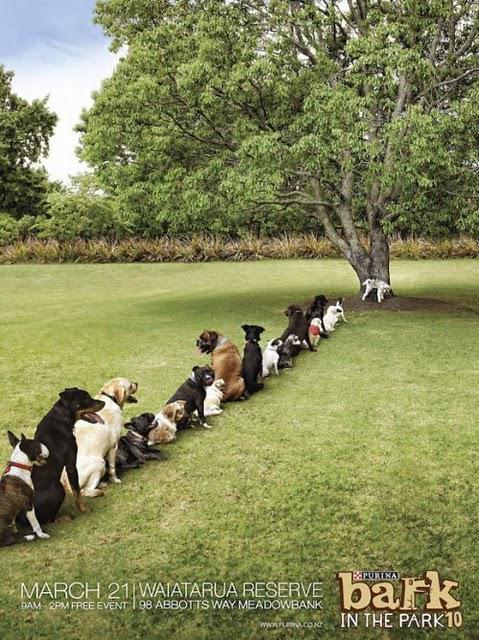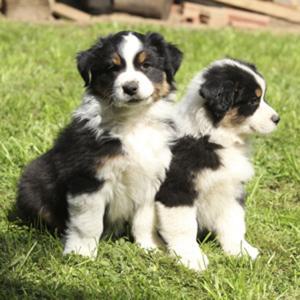The first image is the image on the left, the second image is the image on the right. For the images displayed, is the sentence "The left image includes one brown-and-white dog, and the right image shows one multi-colored spotted dog." factually correct? Answer yes or no. No. The first image is the image on the left, the second image is the image on the right. For the images shown, is this caption "There is no more than two dogs." true? Answer yes or no. No. 